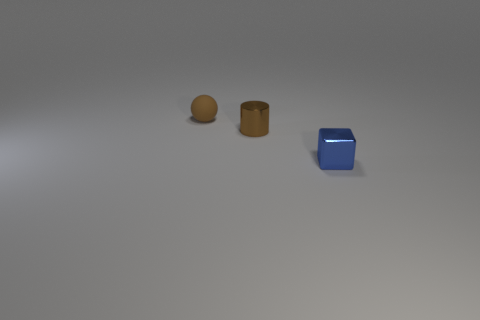Add 2 large cyan balls. How many objects exist? 5 Subtract all spheres. How many objects are left? 2 Subtract 0 purple blocks. How many objects are left? 3 Subtract all brown metal cylinders. Subtract all small brown metallic objects. How many objects are left? 1 Add 1 small blue metallic cubes. How many small blue metallic cubes are left? 2 Add 3 small purple matte cylinders. How many small purple matte cylinders exist? 3 